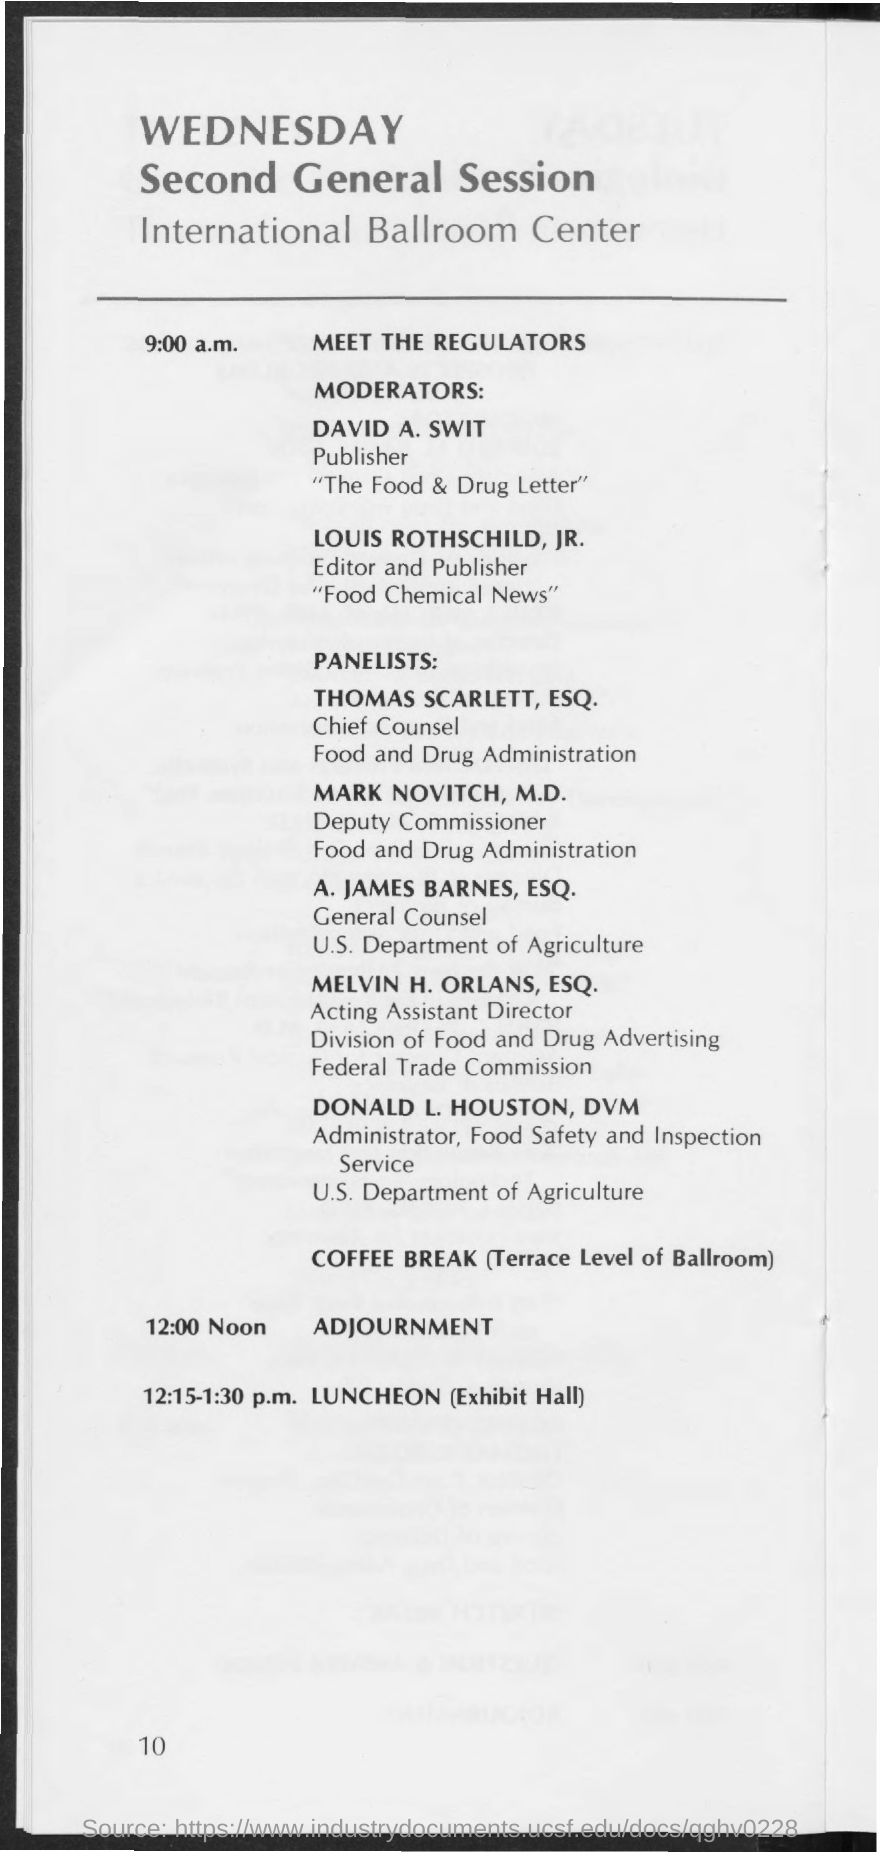Identify some key points in this picture. The event "Meet the Regulators" is scheduled to begin at 9:00 a.m. The luncheon will take place from 12:15-1:30 p.m. The adjournment is scheduled for 12:00 noon. 